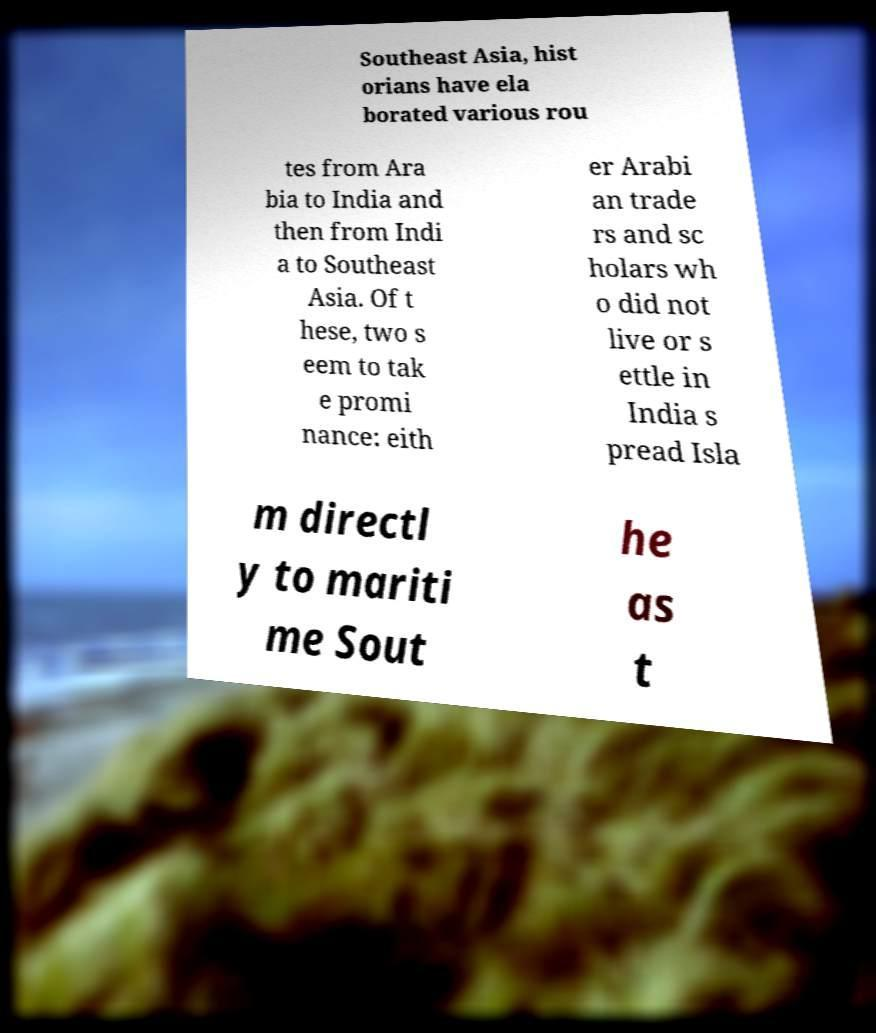What messages or text are displayed in this image? I need them in a readable, typed format. Southeast Asia, hist orians have ela borated various rou tes from Ara bia to India and then from Indi a to Southeast Asia. Of t hese, two s eem to tak e promi nance: eith er Arabi an trade rs and sc holars wh o did not live or s ettle in India s pread Isla m directl y to mariti me Sout he as t 